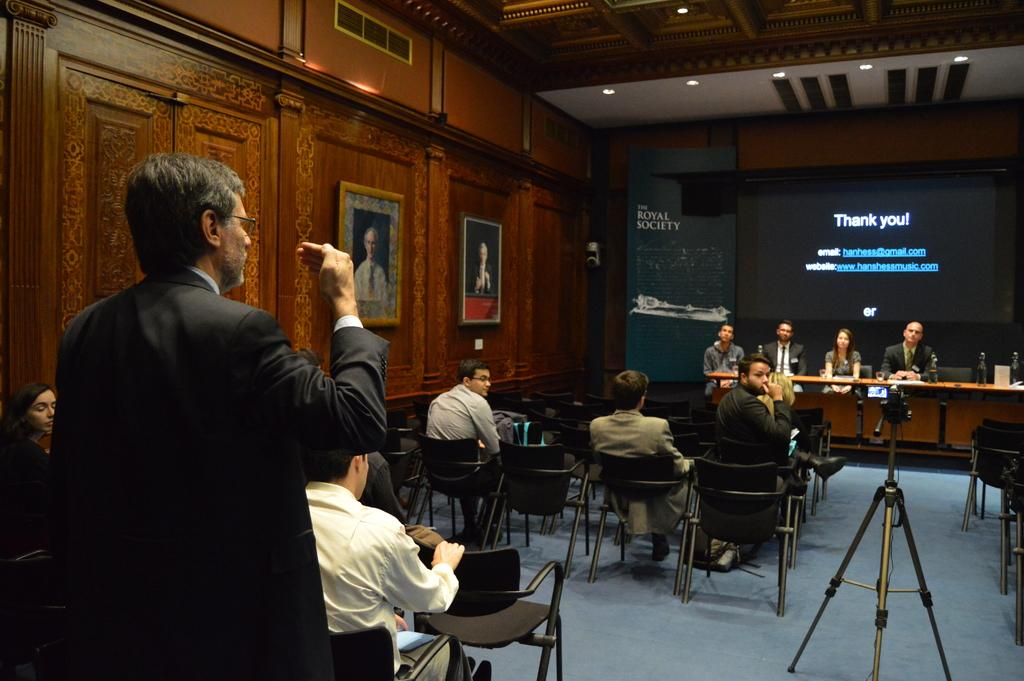What are the people in the image doing? The people in the image are sitting on chairs. What can be seen on the screen in the image? The facts do not specify what is on the screen. What is the source of light in the image? The facts do not specify the source of light. What type of objects are present in the image? There are frames in the image. What is the man in the image doing? The man is standing and looking at the screen. How many cows are present in the image? There are no cows present in the image. What type of mint is being used to freshen the air in the image? There is no mention of mint or any freshening of the air in the image. 